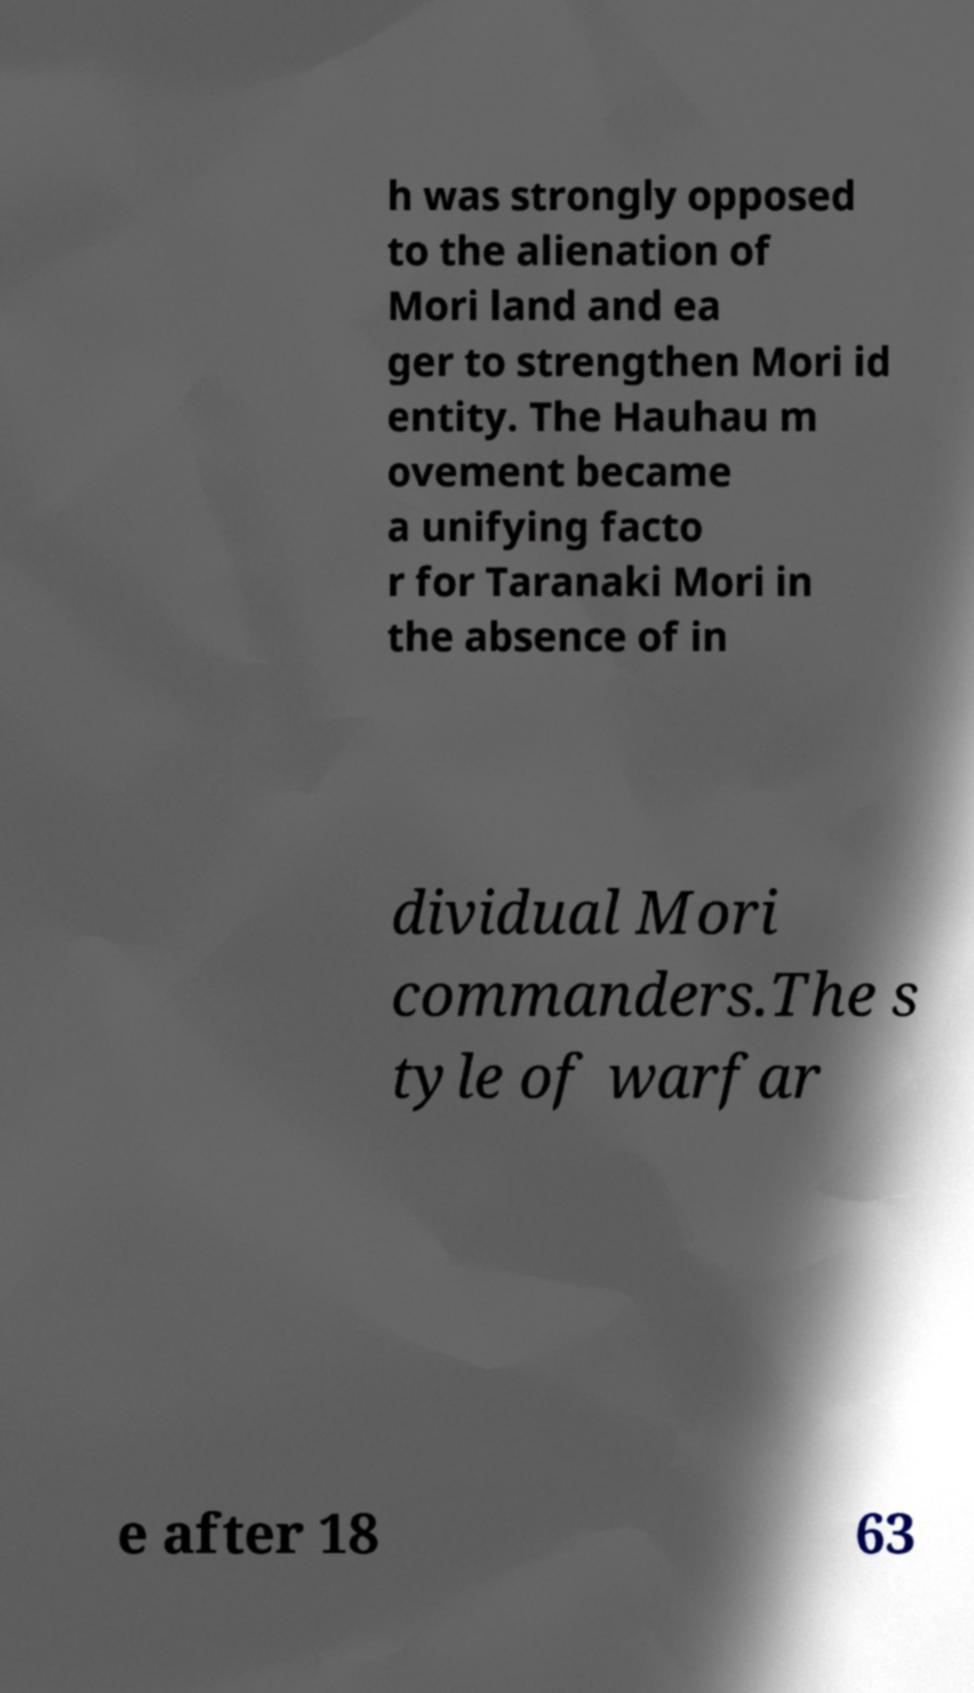For documentation purposes, I need the text within this image transcribed. Could you provide that? h was strongly opposed to the alienation of Mori land and ea ger to strengthen Mori id entity. The Hauhau m ovement became a unifying facto r for Taranaki Mori in the absence of in dividual Mori commanders.The s tyle of warfar e after 18 63 